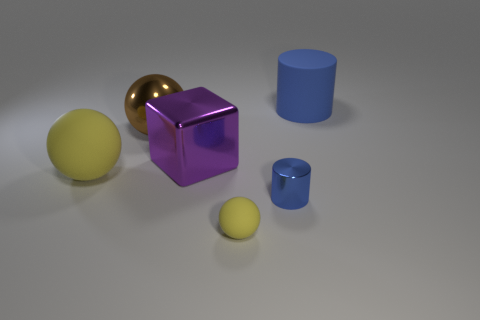What number of things are balls behind the big shiny block or yellow objects?
Your response must be concise. 3. Are there fewer blue metal cylinders than green metallic blocks?
Provide a short and direct response. No. What shape is the small blue thing that is made of the same material as the large purple cube?
Provide a short and direct response. Cylinder. There is a tiny cylinder; are there any blue matte things on the left side of it?
Ensure brevity in your answer.  No. Are there fewer things that are in front of the tiny metal cylinder than tiny brown balls?
Make the answer very short. No. What material is the small sphere?
Offer a terse response. Rubber. The big block is what color?
Provide a short and direct response. Purple. There is a thing that is both in front of the purple object and behind the tiny blue shiny cylinder; what color is it?
Ensure brevity in your answer.  Yellow. Is the tiny yellow thing made of the same material as the large ball that is behind the large yellow ball?
Ensure brevity in your answer.  No. What is the size of the blue cylinder that is behind the ball to the left of the large metal ball?
Your answer should be very brief. Large. 